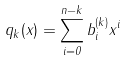Convert formula to latex. <formula><loc_0><loc_0><loc_500><loc_500>q _ { k } ( x ) = \sum _ { i = 0 } ^ { n - k } b ^ { ( k ) } _ { i } x ^ { i }</formula> 